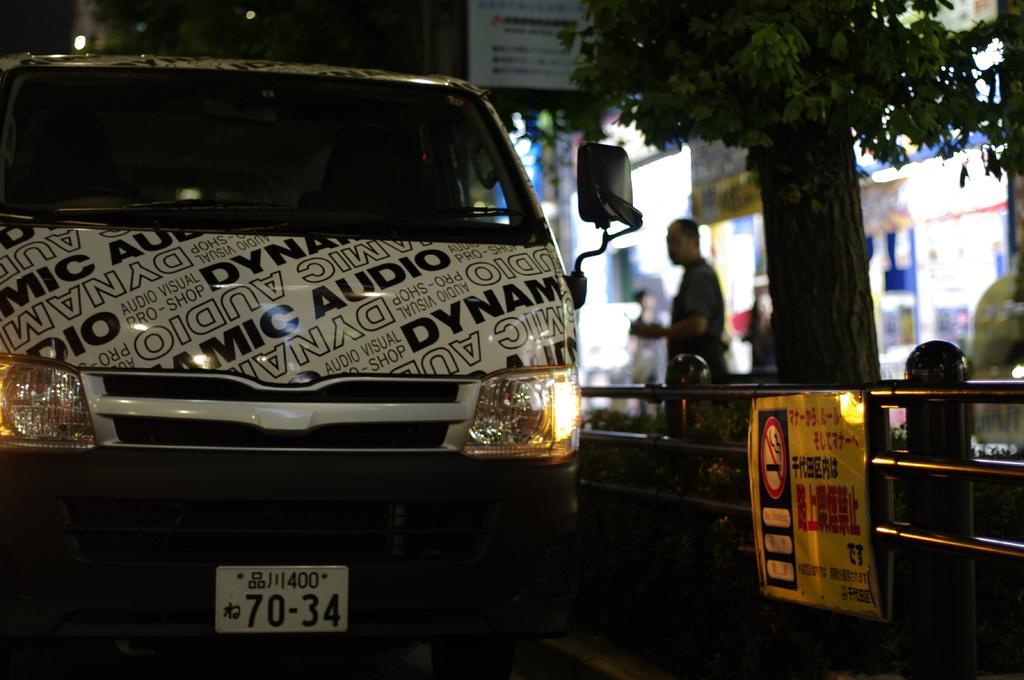Describe this image in one or two sentences. In this image in the front there is a vehicle with some text and numbers written on it. On the right side there is a railing and on the railing there is a board with some text written on it and there is a tree and there is a person visible and the background is blurry and on the top there is a board with some text written on it. 